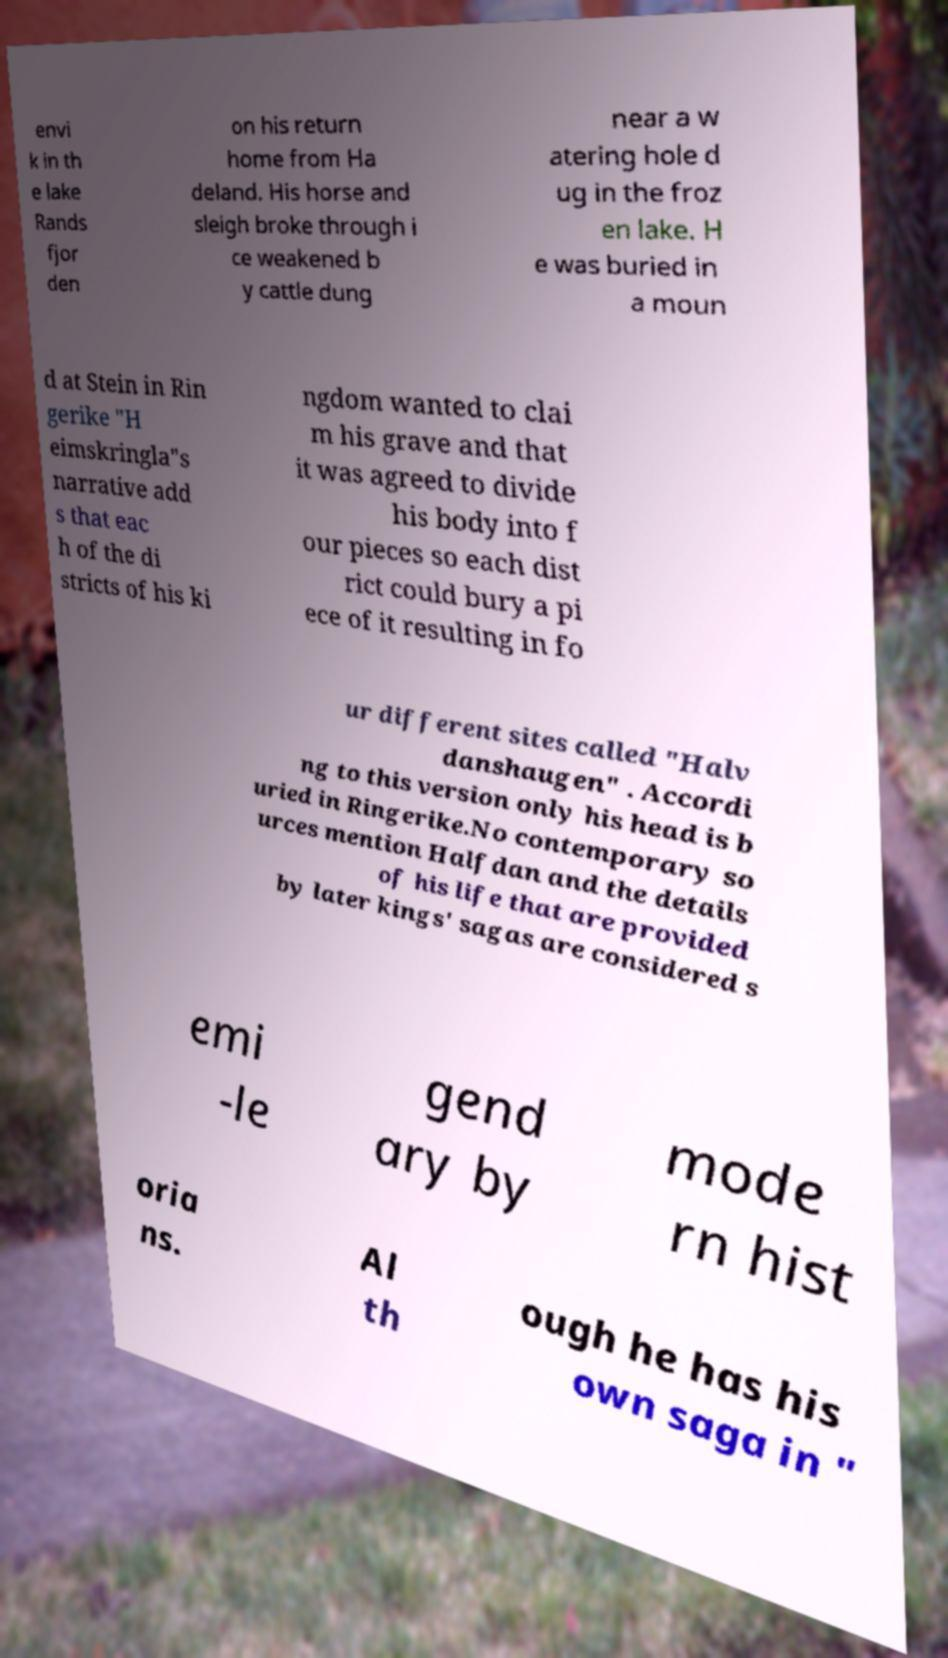Please identify and transcribe the text found in this image. envi k in th e lake Rands fjor den on his return home from Ha deland. His horse and sleigh broke through i ce weakened b y cattle dung near a w atering hole d ug in the froz en lake. H e was buried in a moun d at Stein in Rin gerike "H eimskringla"s narrative add s that eac h of the di stricts of his ki ngdom wanted to clai m his grave and that it was agreed to divide his body into f our pieces so each dist rict could bury a pi ece of it resulting in fo ur different sites called "Halv danshaugen" . Accordi ng to this version only his head is b uried in Ringerike.No contemporary so urces mention Halfdan and the details of his life that are provided by later kings' sagas are considered s emi -le gend ary by mode rn hist oria ns. Al th ough he has his own saga in " 